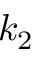Convert formula to latex. <formula><loc_0><loc_0><loc_500><loc_500>k _ { 2 }</formula> 